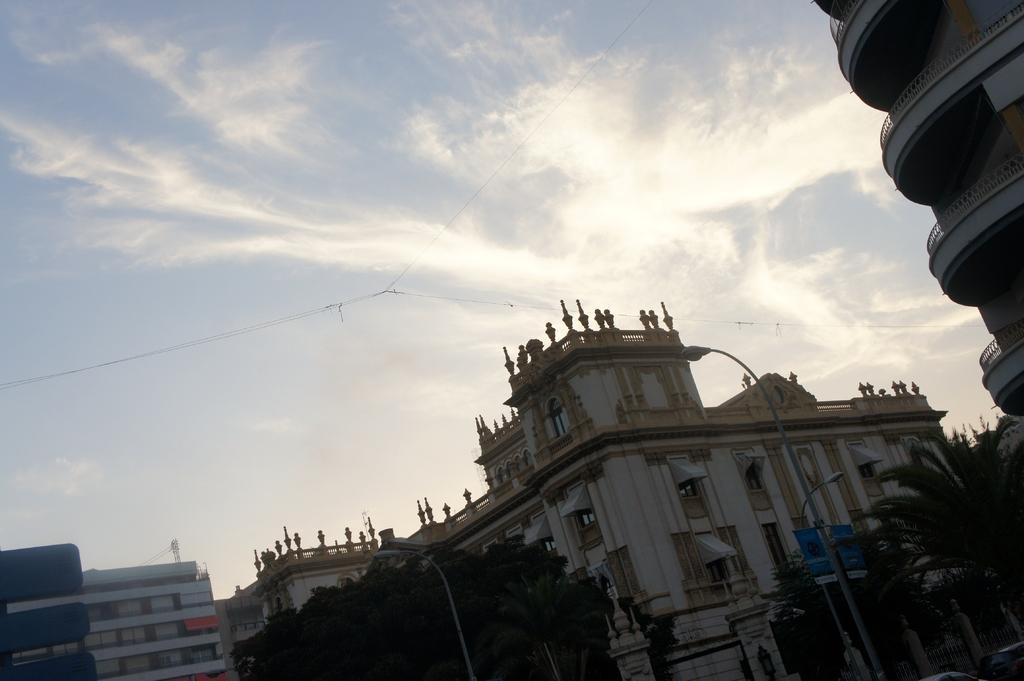Please provide a concise description of this image. In this picture I can see buildings, trees and few pole lights and I can see couple of cars at the bottom right corner of the picture and I can see a banner to the pole and a blue cloudy sky. 